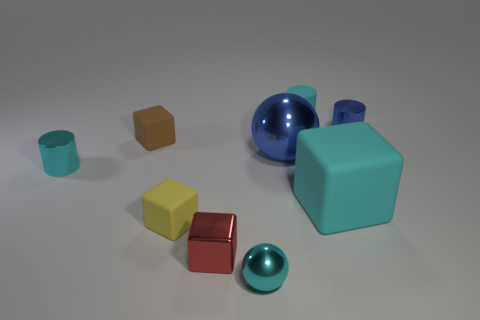How many other things are there of the same shape as the brown object?
Keep it short and to the point. 3. The cyan metallic cylinder is what size?
Your response must be concise. Small. What size is the rubber thing that is both behind the small cyan metal cylinder and in front of the blue shiny cylinder?
Your answer should be very brief. Small. There is a cyan object that is left of the red block; what shape is it?
Provide a short and direct response. Cylinder. Do the tiny red block and the thing in front of the shiny cube have the same material?
Provide a succinct answer. Yes. Is the shape of the large blue object the same as the small red thing?
Make the answer very short. No. There is a brown object that is the same shape as the tiny yellow rubber object; what is it made of?
Your answer should be very brief. Rubber. What color is the matte thing that is both in front of the tiny blue metal thing and right of the big ball?
Offer a terse response. Cyan. What color is the metal block?
Offer a very short reply. Red. There is a large cube that is the same color as the small sphere; what material is it?
Your response must be concise. Rubber. 